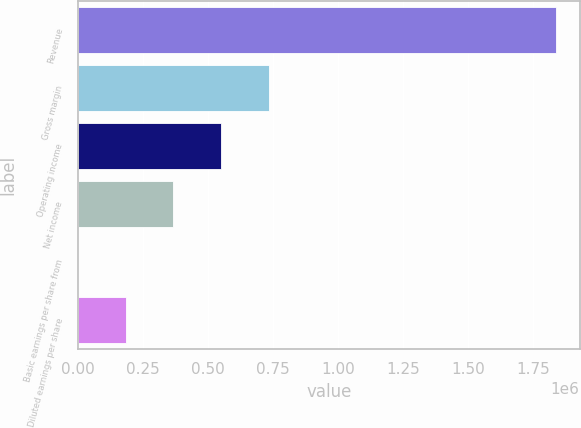Convert chart to OTSL. <chart><loc_0><loc_0><loc_500><loc_500><bar_chart><fcel>Revenue<fcel>Gross margin<fcel>Operating income<fcel>Net income<fcel>Basic earnings per share from<fcel>Diluted earnings per share<nl><fcel>1.83807e+06<fcel>735228<fcel>551421<fcel>367614<fcel>0.39<fcel>183807<nl></chart> 